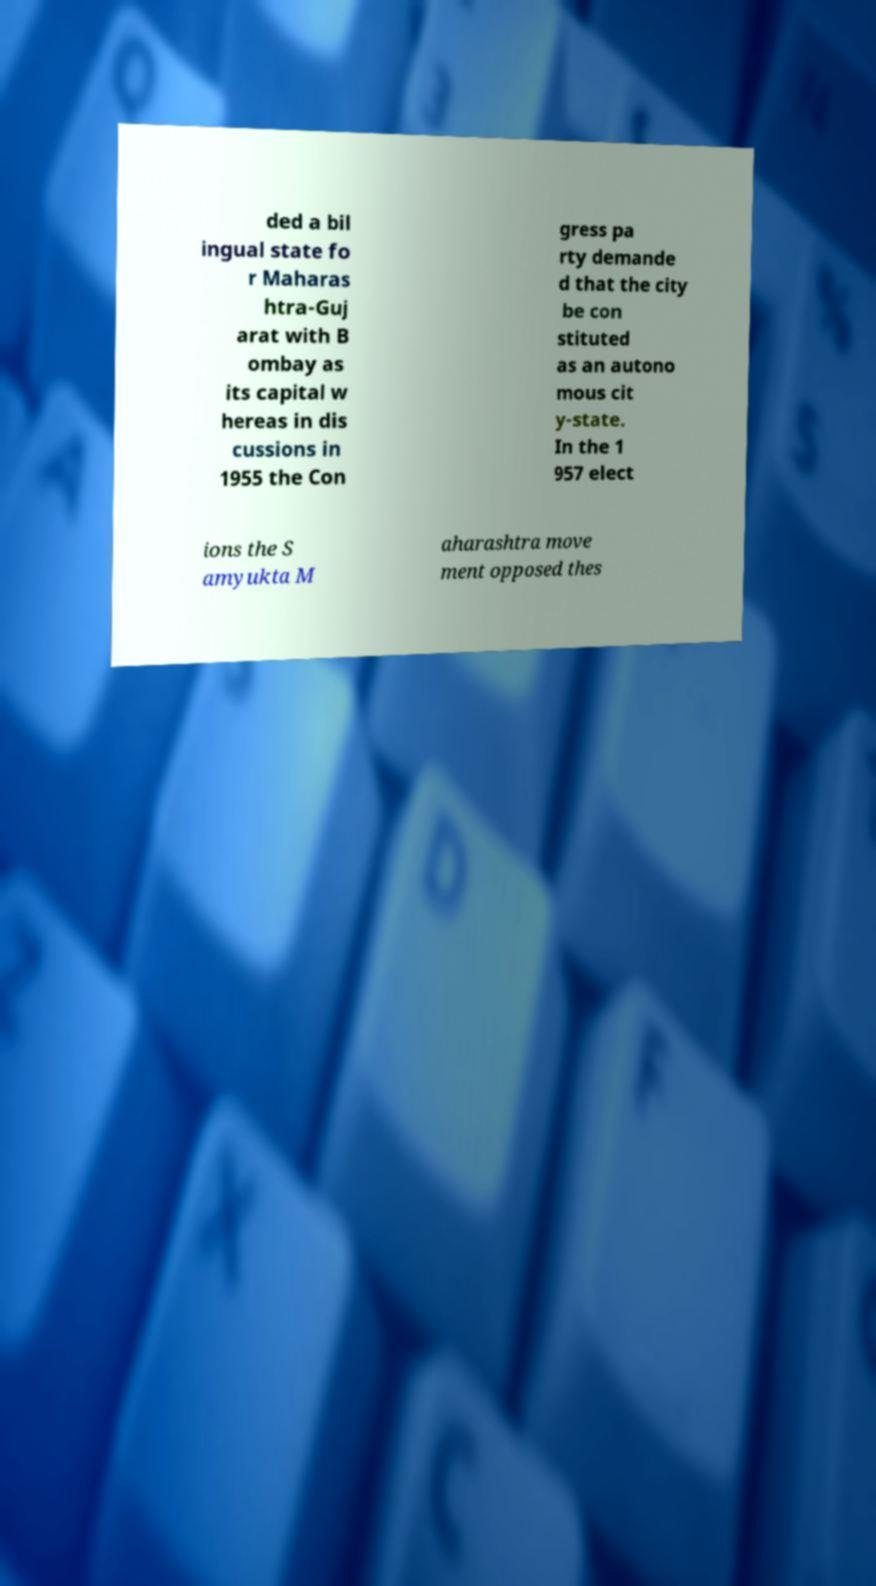I need the written content from this picture converted into text. Can you do that? ded a bil ingual state fo r Maharas htra-Guj arat with B ombay as its capital w hereas in dis cussions in 1955 the Con gress pa rty demande d that the city be con stituted as an autono mous cit y-state. In the 1 957 elect ions the S amyukta M aharashtra move ment opposed thes 